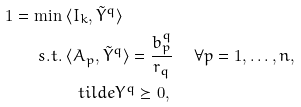Convert formula to latex. <formula><loc_0><loc_0><loc_500><loc_500>1 = \min & \ \langle I _ { k } , \tilde { Y } ^ { q } \rangle \\ s . t . & \ \langle A _ { p } , \tilde { Y } ^ { q } \rangle = \frac { b ^ { q } _ { p } } { r _ { q } } \ \quad \forall p = 1 , \dots , n , \\ & \quad t i l d e { Y } ^ { q } \succeq 0 ,</formula> 